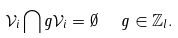<formula> <loc_0><loc_0><loc_500><loc_500>\mathcal { V } _ { i } \bigcap g \mathcal { V } _ { i } = \emptyset \ \ g \in \mathbb { Z } _ { l } .</formula> 